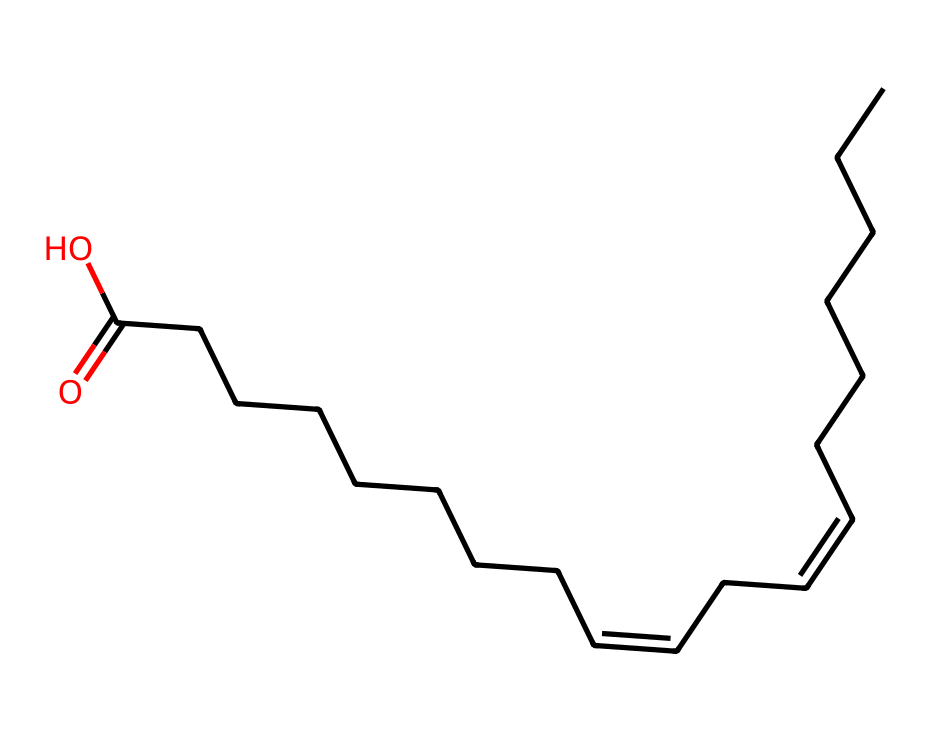What is the main functional group in linoleic acid? The SMILES representation shows a carboxylic acid functional group due to the presence of the -C(=O)O structure at the end of the carbon chain.
Answer: carboxylic acid How many carbon atoms are in linoleic acid? By interpreting the SMILES, we count 18 carbon atoms represented by the "C" characters, including those in the double bonds.
Answer: eighteen What type of isomerism is present in linoleic acid? The presence of double bonds in the carbon chain allows for different spatial arrangements of the substituents, indicating that E-Z isomerism occurs due to the geometric configuration around these double bonds.
Answer: E-Z isomerism How many double bonds are present in linoleic acid? The SMILES shows two instances of "/C=C\" which correspond to two double bonds in the structure of linoleic acid.
Answer: two What are the E-Z configurations related to in linoleic acid? The E-Z configurations relate to the arrangement of hydrogen and carbon substituents on either side of the double bonds, influencing the geometric isomers' shape and properties.
Answer: hydrogen and carbon substituents Which configuration represents the higher priority groups on opposite sides in one of the double bonds? In the E configuration, the higher priority substituents on either side of a double bond are on opposite sides, which can be determined using the Cahn-Ingold-Prelog priority rules based on atomic numbers.
Answer: E configuration 